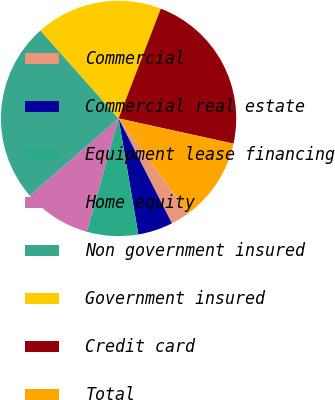Convert chart. <chart><loc_0><loc_0><loc_500><loc_500><pie_chart><fcel>Commercial<fcel>Commercial real estate<fcel>Equipment lease financing<fcel>Home equity<fcel>Non government insured<fcel>Government insured<fcel>Credit card<fcel>Total<nl><fcel>2.59%<fcel>4.81%<fcel>7.04%<fcel>9.26%<fcel>24.81%<fcel>17.41%<fcel>22.59%<fcel>11.48%<nl></chart> 